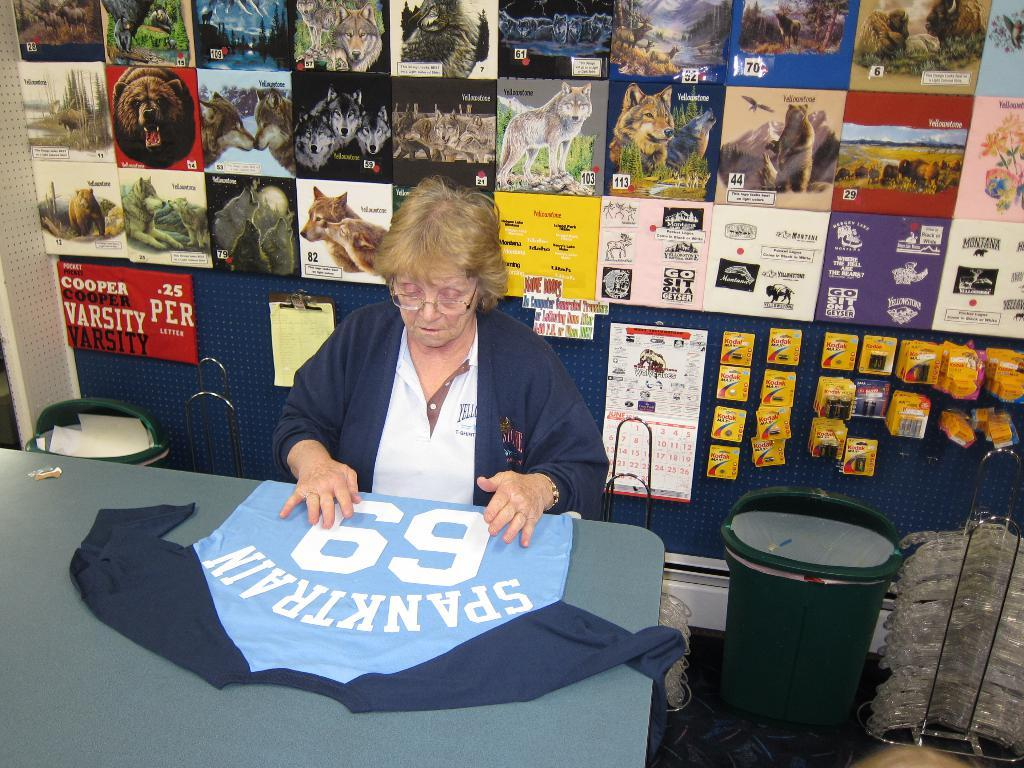<image>
Summarize the visual content of the image. Older woman sitting next to a jersey that says 69 on it. 